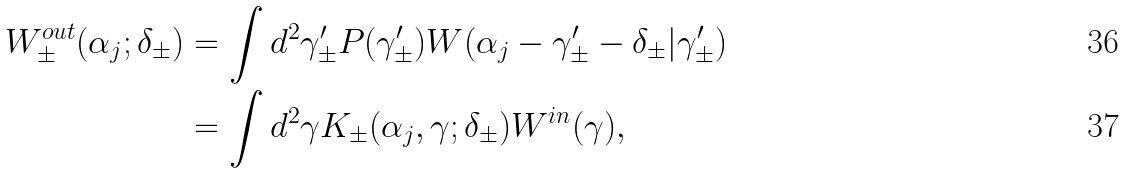<formula> <loc_0><loc_0><loc_500><loc_500>W _ { \pm } ^ { o u t } ( \alpha _ { j } ; \delta _ { \pm } ) & = \int d ^ { 2 } \gamma _ { \pm } ^ { \prime } P ( \gamma _ { \pm } ^ { \prime } ) W ( \alpha _ { j } - \gamma _ { \pm } ^ { \prime } - \delta _ { \pm } | \gamma _ { \pm } ^ { \prime } ) \\ & = \int d ^ { 2 } \gamma K _ { \pm } ( \alpha _ { j } , \gamma ; \delta _ { \pm } ) W ^ { i n } ( \gamma ) ,</formula> 